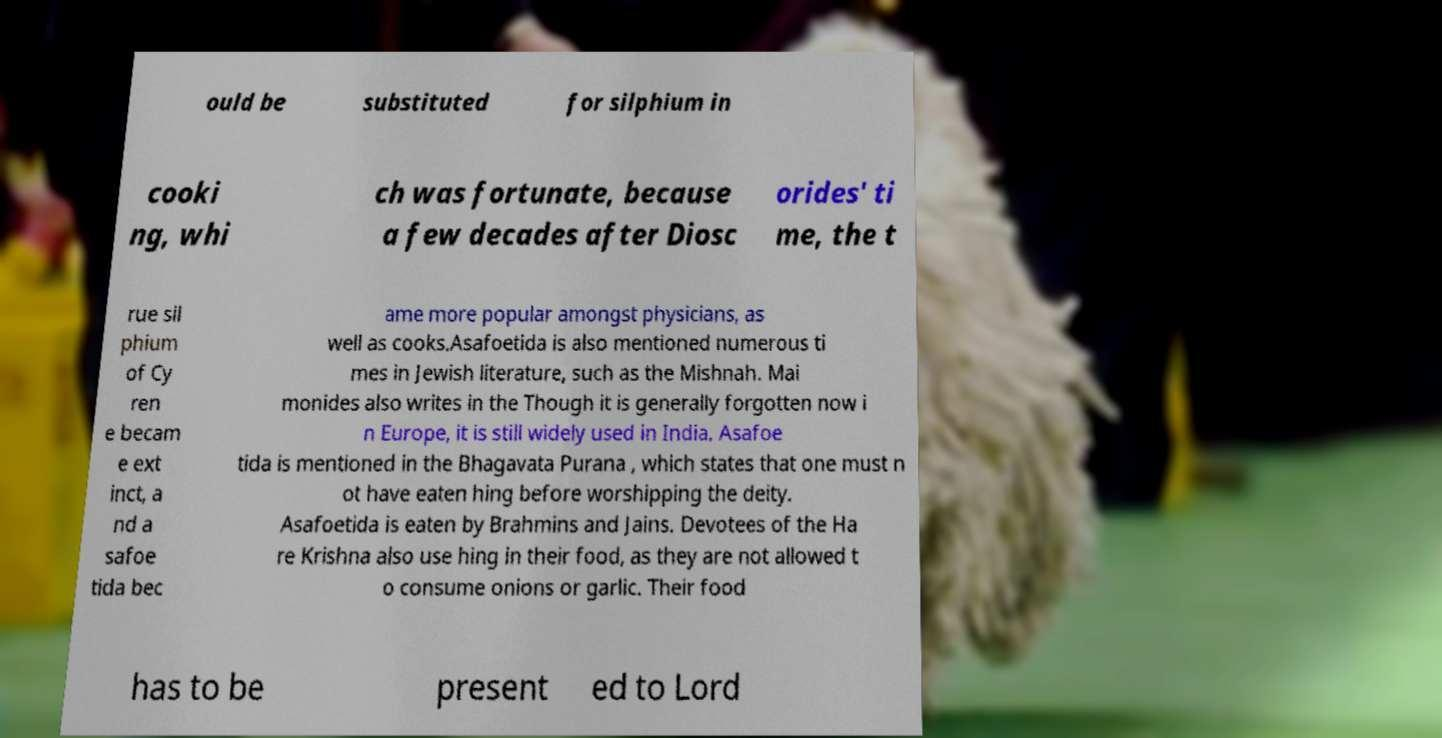Can you read and provide the text displayed in the image?This photo seems to have some interesting text. Can you extract and type it out for me? ould be substituted for silphium in cooki ng, whi ch was fortunate, because a few decades after Diosc orides' ti me, the t rue sil phium of Cy ren e becam e ext inct, a nd a safoe tida bec ame more popular amongst physicians, as well as cooks.Asafoetida is also mentioned numerous ti mes in Jewish literature, such as the Mishnah. Mai monides also writes in the Though it is generally forgotten now i n Europe, it is still widely used in India. Asafoe tida is mentioned in the Bhagavata Purana , which states that one must n ot have eaten hing before worshipping the deity. Asafoetida is eaten by Brahmins and Jains. Devotees of the Ha re Krishna also use hing in their food, as they are not allowed t o consume onions or garlic. Their food has to be present ed to Lord 